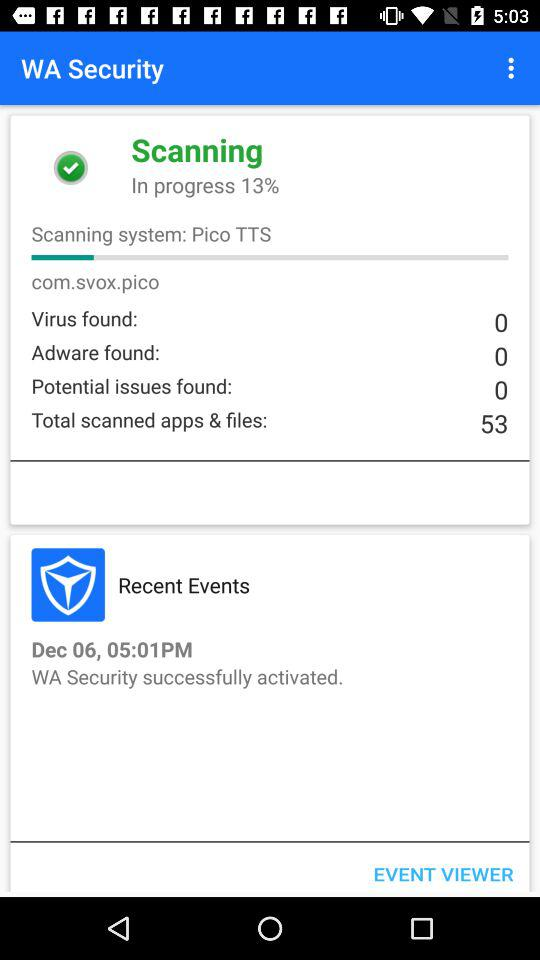What is the total number of scanned apps and files? The total number is 53. 